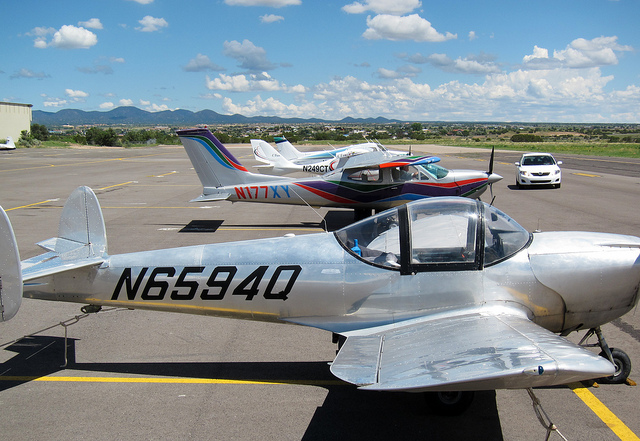Is there a specific reason why different types of aircraft might be parked together on the tarmac? Different types of aircraft can be parked together on the tarmac for several reasons, such as space availability, airport organization, or because they might be operated by the same flying club or school. It's a common sight at general aviation airports where a variety of planes can be seen. 